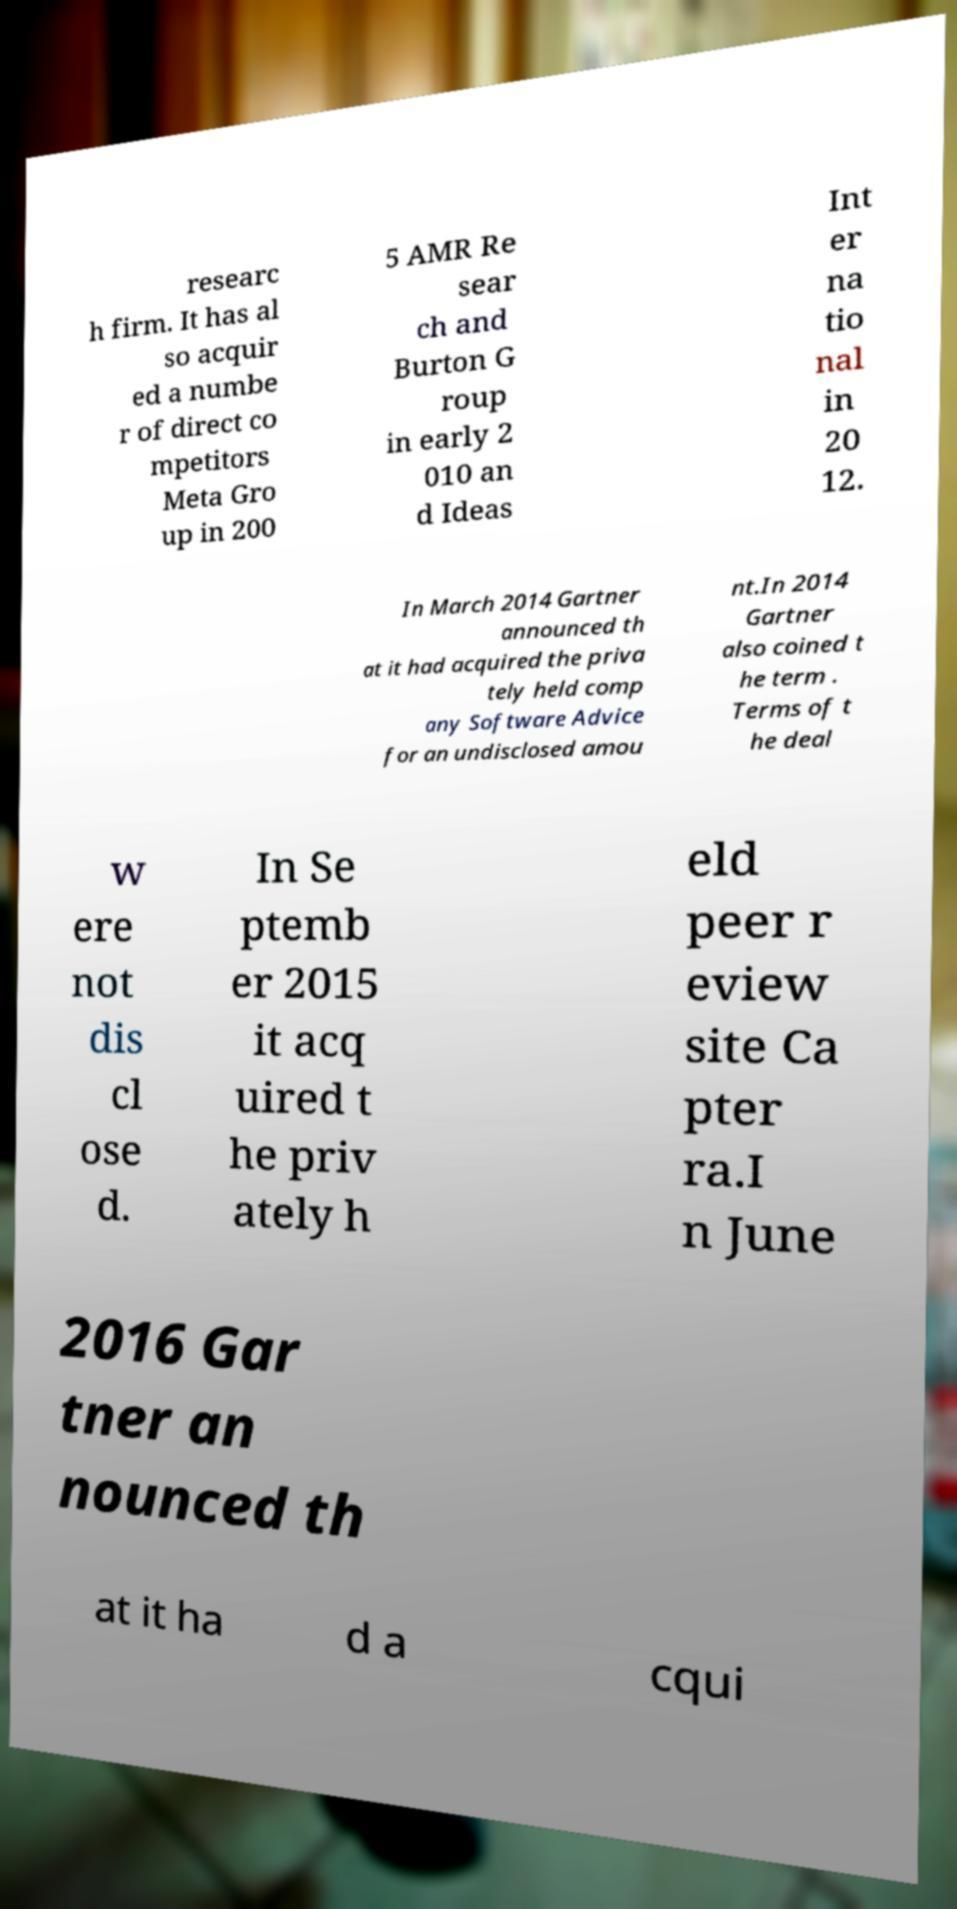I need the written content from this picture converted into text. Can you do that? researc h firm. It has al so acquir ed a numbe r of direct co mpetitors Meta Gro up in 200 5 AMR Re sear ch and Burton G roup in early 2 010 an d Ideas Int er na tio nal in 20 12. In March 2014 Gartner announced th at it had acquired the priva tely held comp any Software Advice for an undisclosed amou nt.In 2014 Gartner also coined t he term . Terms of t he deal w ere not dis cl ose d. In Se ptemb er 2015 it acq uired t he priv ately h eld peer r eview site Ca pter ra.I n June 2016 Gar tner an nounced th at it ha d a cqui 